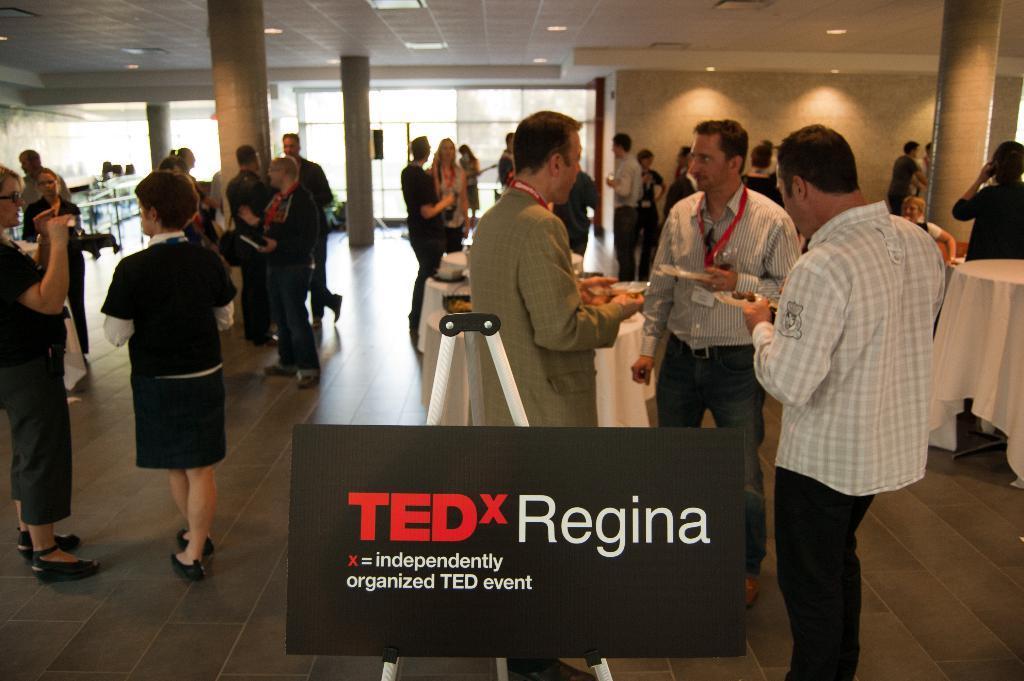How would you summarize this image in a sentence or two? In this image we can see a group of people standing on the floor. In that some are holding the plates containing food in it. We can also see some objects on a table, pillars, windows, wall and a roof with some ceiling lights. In the foreground we can see a board on a stand with some text on it. 